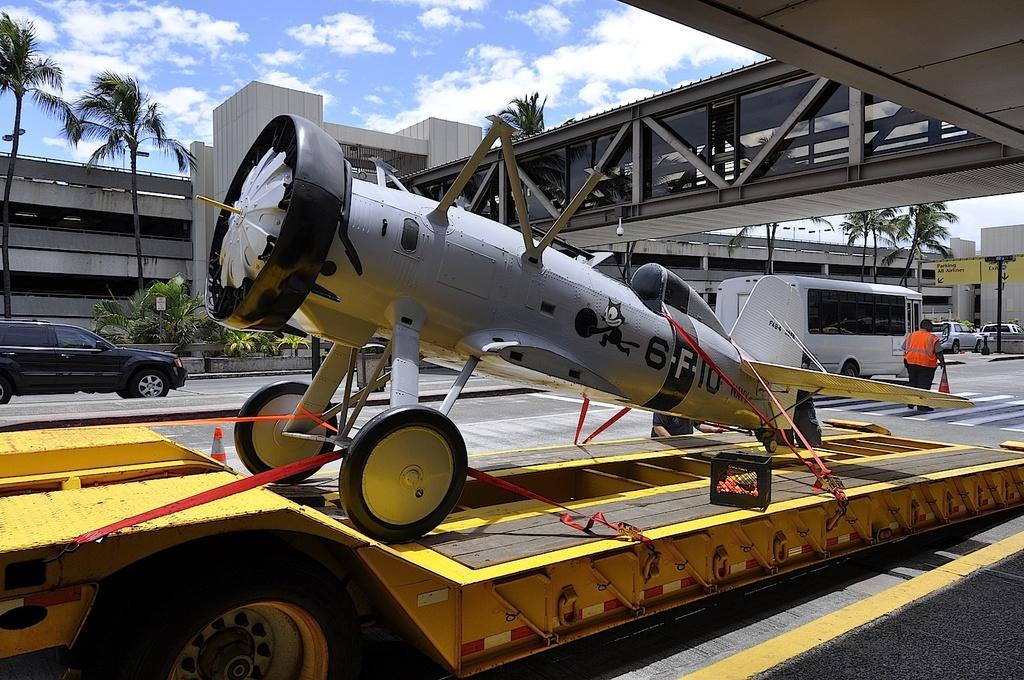<image>
Summarize the visual content of the image. A plane on a trailer with the letters and numbers"6F10" written upon the side. 